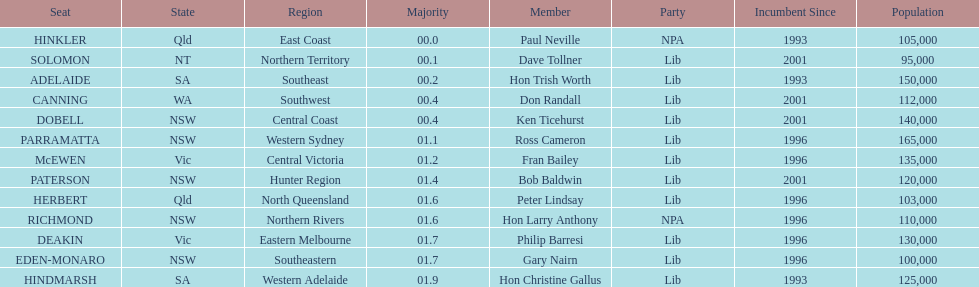How many members in total? 13. 